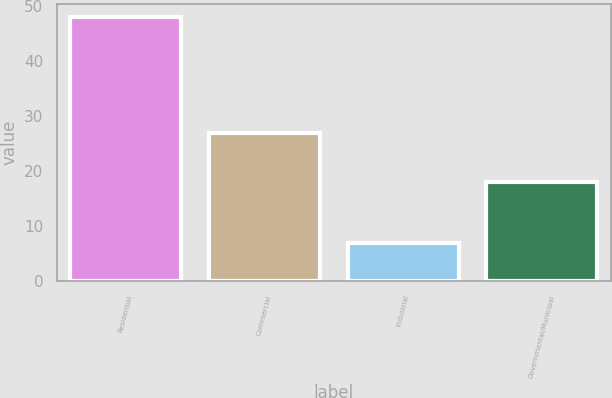Convert chart. <chart><loc_0><loc_0><loc_500><loc_500><bar_chart><fcel>Residential<fcel>Commercial<fcel>Industrial<fcel>Governmental/Municipal<nl><fcel>48<fcel>27<fcel>7<fcel>18<nl></chart> 